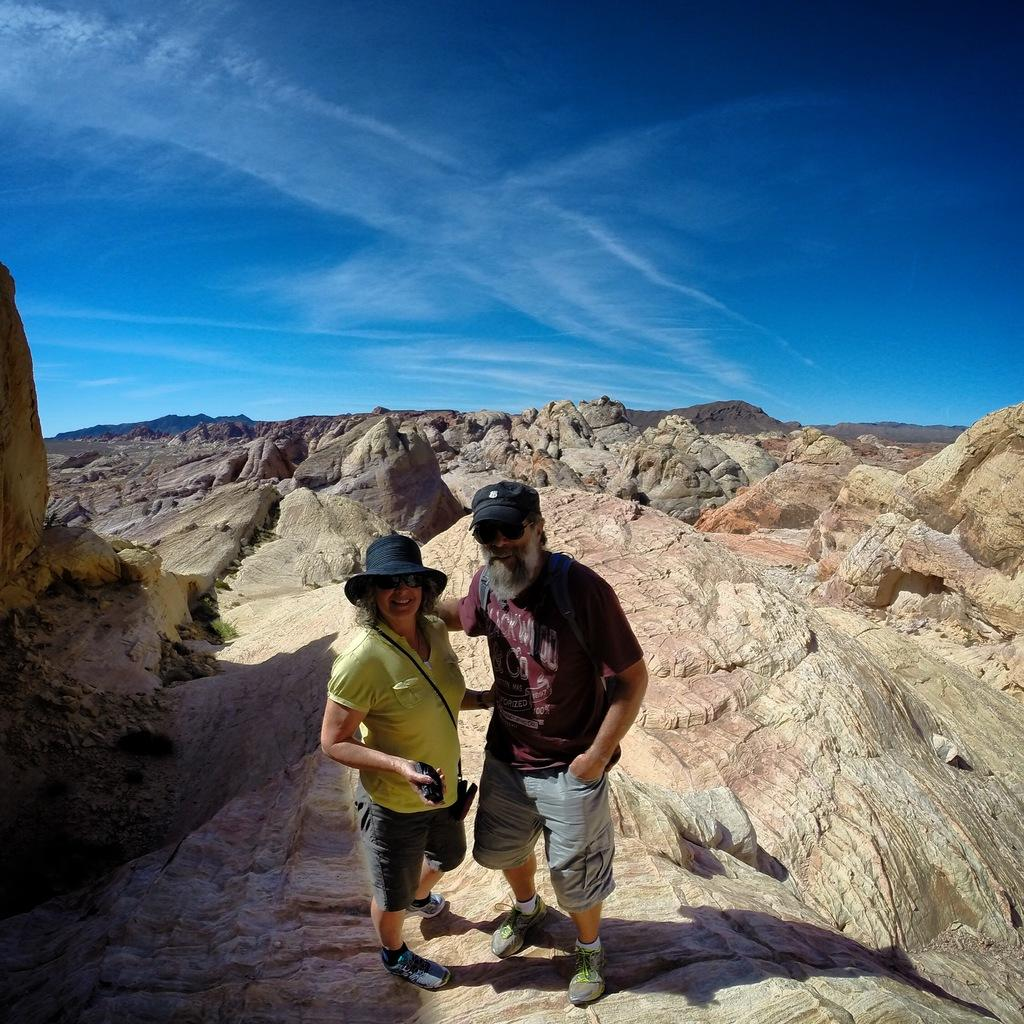Who are the people in the image? There is a man and a woman in the image. Where are the man and woman located in the image? Both the man and the woman are on a rock. What else can be seen in the center of the image? There are rocks in the center of the image. What type of paste is being used by the man and woman in the image? There is no paste present in the image; the man and woman are simply standing on a rock. 